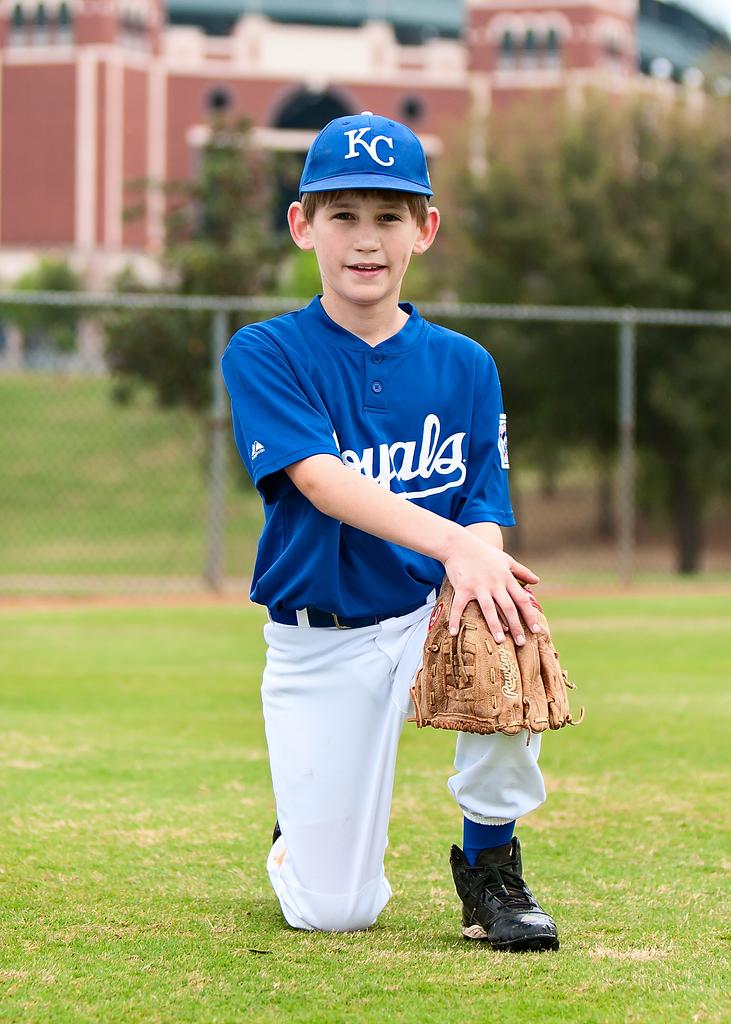What is the name of the baseball team?
Offer a terse response. Royals. What color is the glove?
Your answer should be compact. Answering does not require reading text in the image. 